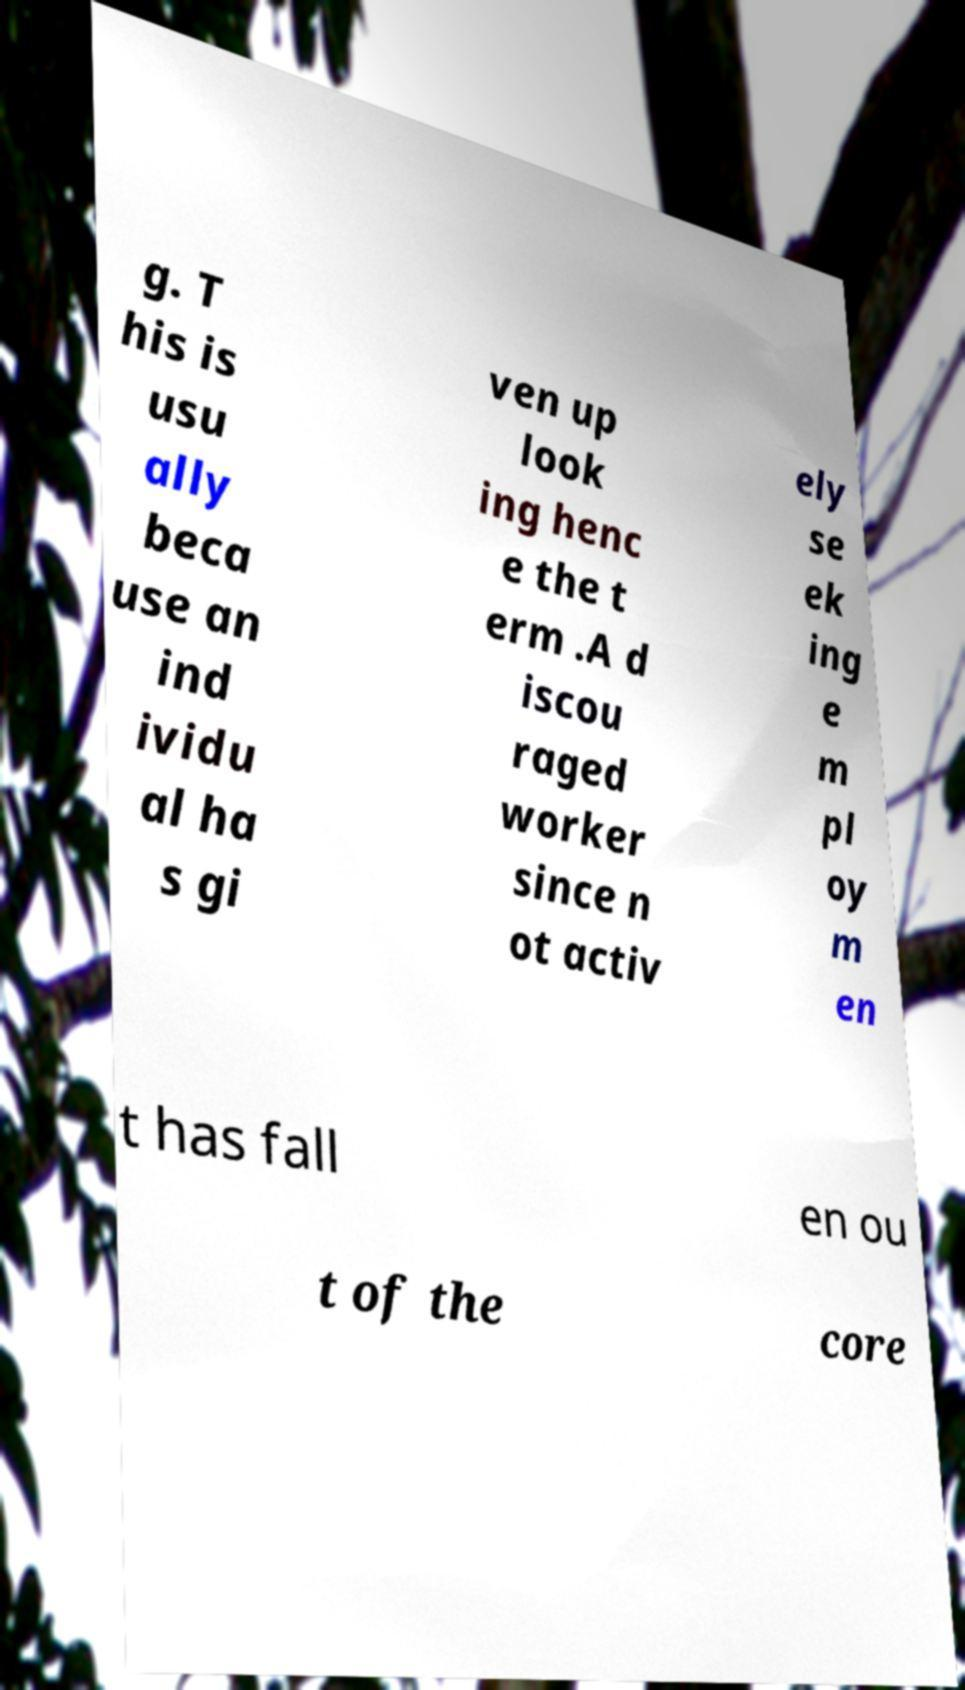Can you read and provide the text displayed in the image?This photo seems to have some interesting text. Can you extract and type it out for me? g. T his is usu ally beca use an ind ividu al ha s gi ven up look ing henc e the t erm .A d iscou raged worker since n ot activ ely se ek ing e m pl oy m en t has fall en ou t of the core 